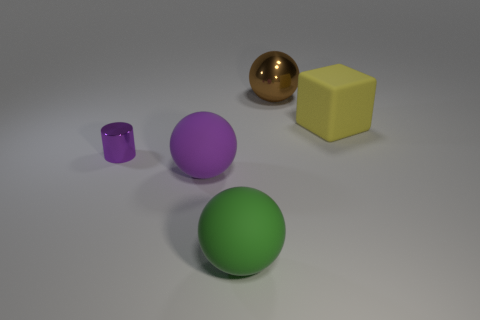Add 1 large purple spheres. How many objects exist? 6 Subtract all balls. How many objects are left? 2 Add 2 large green spheres. How many large green spheres exist? 3 Subtract 0 gray spheres. How many objects are left? 5 Subtract all big yellow things. Subtract all yellow matte balls. How many objects are left? 4 Add 2 small purple things. How many small purple things are left? 3 